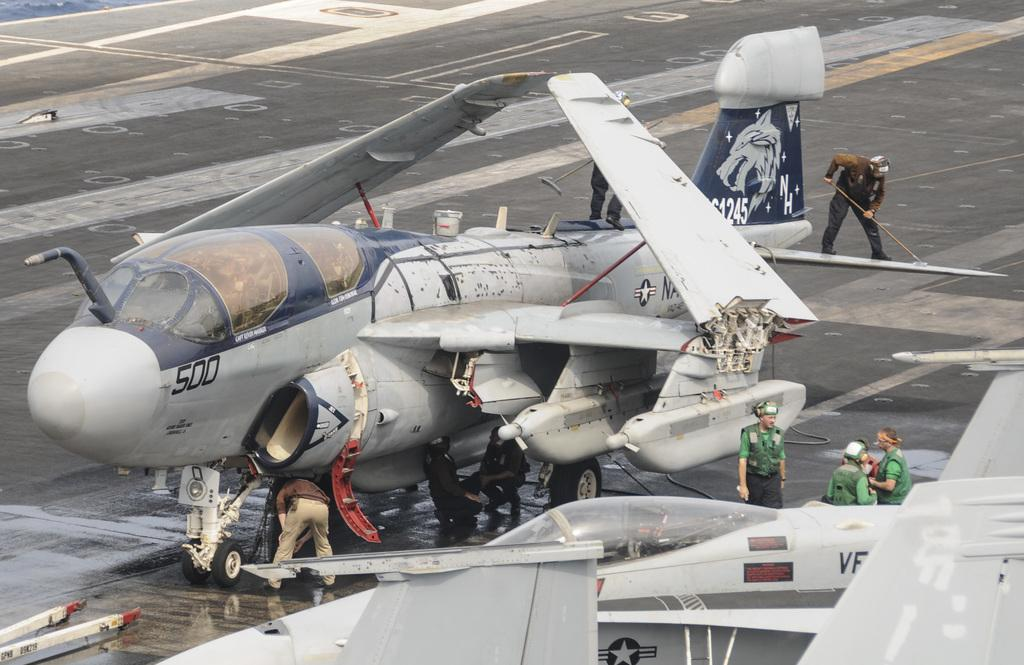<image>
Write a terse but informative summary of the picture. A military plane has the number 500 on its front section. 